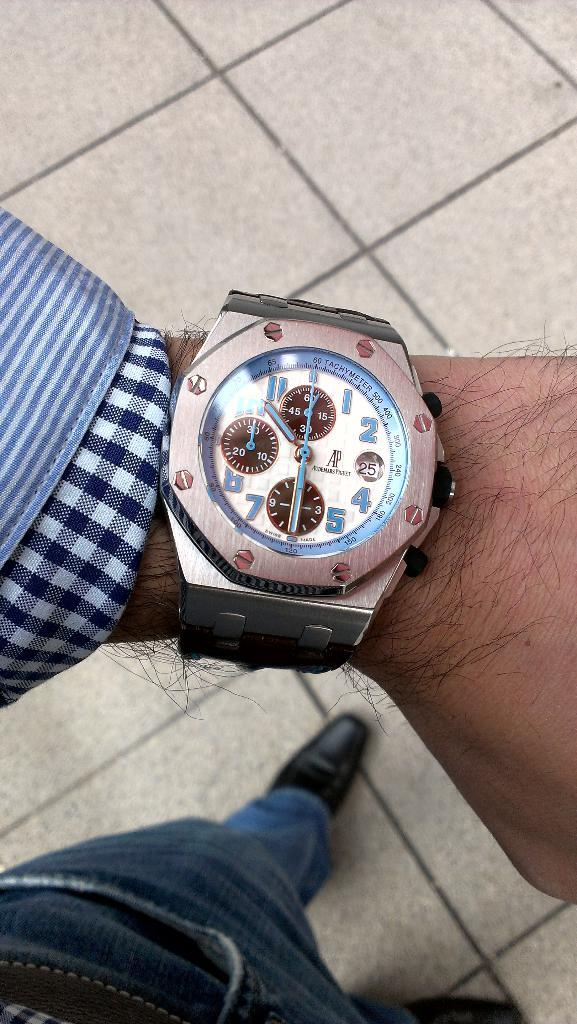<image>
Give a short and clear explanation of the subsequent image. A man's wristwatch with several dials, one of which is pointed at the number 30. 